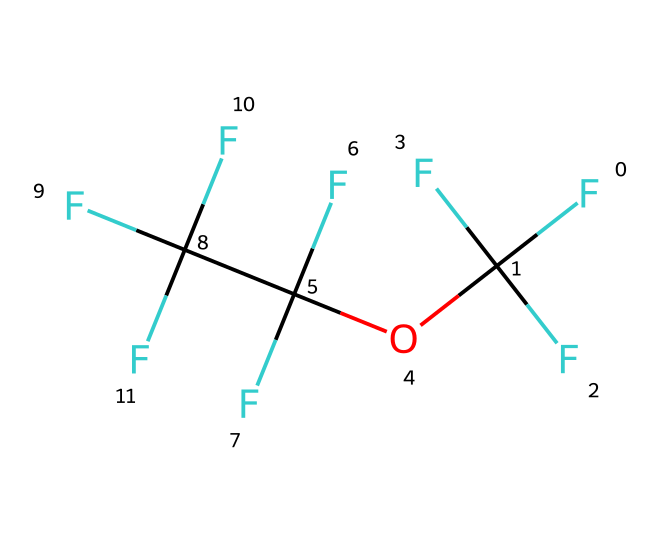What is the total number of carbon atoms in this molecule? The SMILES representation indicates there are four 'C' characters representing carbon atoms. Counting these gives a total of 4 carbon atoms in the structure.
Answer: 4 What functional group is represented in this compound? By analyzing the structure, the presence of the 'O' in the SMILES notation along with the carbon chains indicates that this compound contains an ether functional group.
Answer: ether How many fluorine atoms are present in this molecule? The SMILES notation shows multiple 'F' characters, specifically indicating 8 fluorine atoms in total. Each 'F' represents one fluorine atom.
Answer: 8 Is this chemical polar or non-polar? The presence of multiple fluorine atoms along with the ether indicates that this compound is likely to be non-polar because the fluorine creates strong bonds but does not significantly contribute to overall polarity due to symmetry.
Answer: non-polar Does this compound exhibit high or low volatility? The structure of perfluoroethers suggests that they have low volatility due to their strong bonds and stability; therefore, considering this when observing the chemical characteristics leads to the conclusion of low volatility.
Answer: low volatility Which element is present as an atom in the ether link of this compound? The 'O' present in the SMILES representation indicates that oxygen is part of the ether link in this compound.
Answer: oxygen What property makes this compound suitable for electronic cooling systems? The stable structure and low volatility associated with perfluoroethers allow them to efficiently transfer heat without evaporating, making them ideal for cooling applications.
Answer: heat transfer 